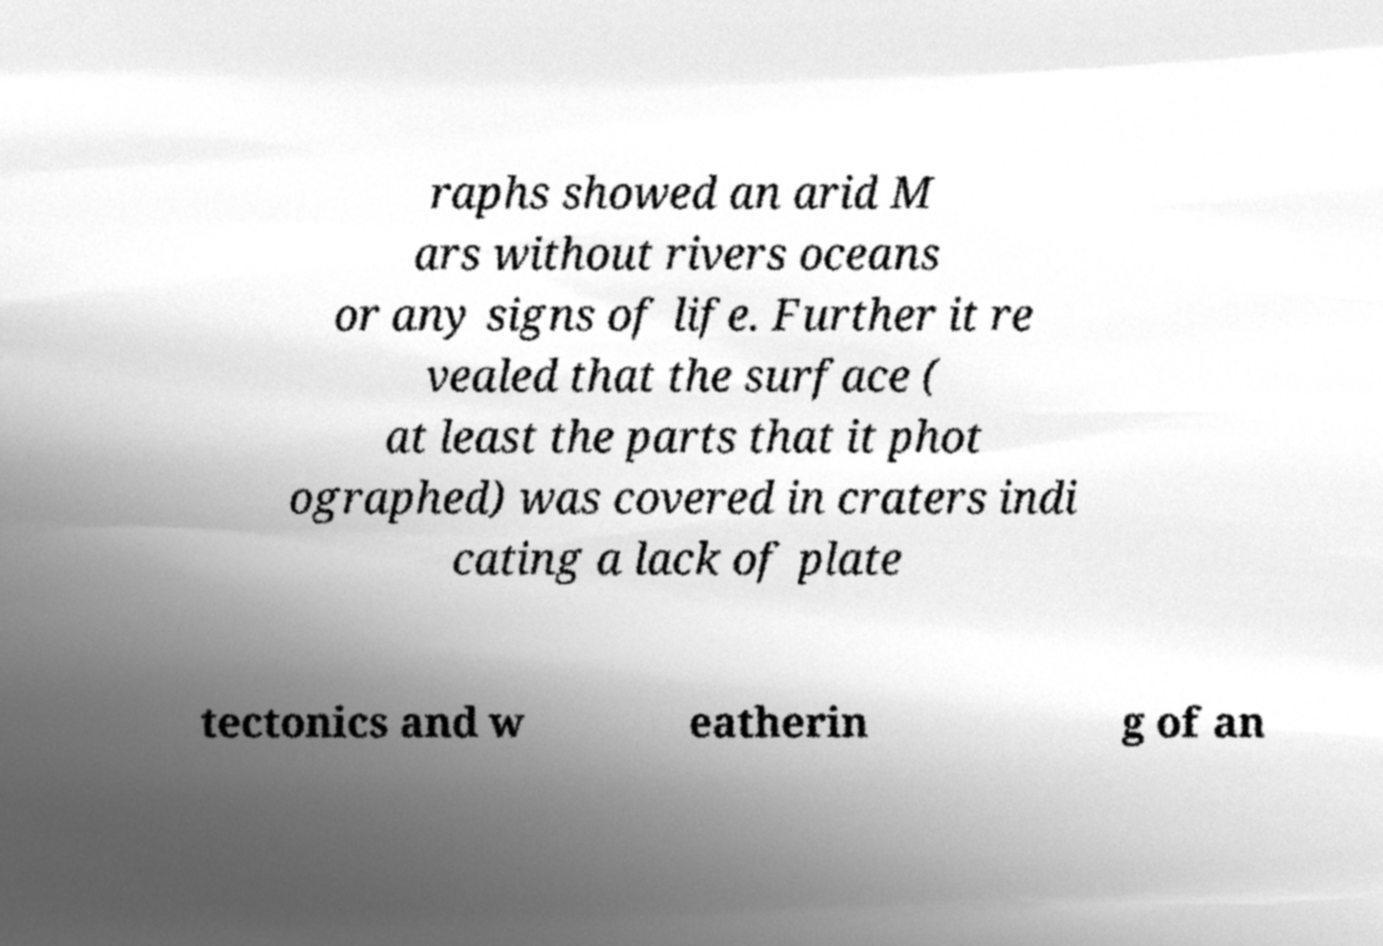Please identify and transcribe the text found in this image. raphs showed an arid M ars without rivers oceans or any signs of life. Further it re vealed that the surface ( at least the parts that it phot ographed) was covered in craters indi cating a lack of plate tectonics and w eatherin g of an 